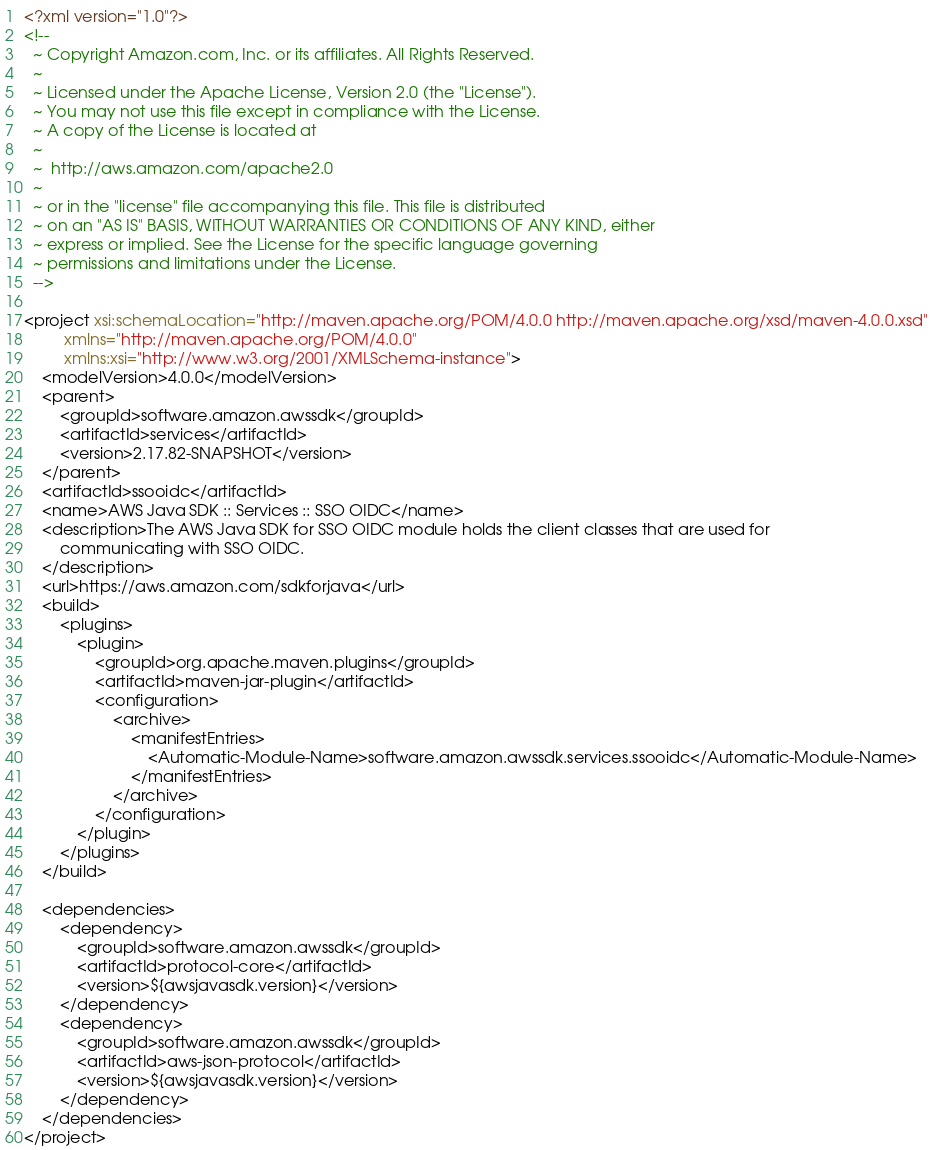<code> <loc_0><loc_0><loc_500><loc_500><_XML_><?xml version="1.0"?>
<!--
  ~ Copyright Amazon.com, Inc. or its affiliates. All Rights Reserved.
  ~
  ~ Licensed under the Apache License, Version 2.0 (the "License").
  ~ You may not use this file except in compliance with the License.
  ~ A copy of the License is located at
  ~
  ~  http://aws.amazon.com/apache2.0
  ~
  ~ or in the "license" file accompanying this file. This file is distributed
  ~ on an "AS IS" BASIS, WITHOUT WARRANTIES OR CONDITIONS OF ANY KIND, either
  ~ express or implied. See the License for the specific language governing
  ~ permissions and limitations under the License.
  -->

<project xsi:schemaLocation="http://maven.apache.org/POM/4.0.0 http://maven.apache.org/xsd/maven-4.0.0.xsd"
         xmlns="http://maven.apache.org/POM/4.0.0"
         xmlns:xsi="http://www.w3.org/2001/XMLSchema-instance">
    <modelVersion>4.0.0</modelVersion>
    <parent>
        <groupId>software.amazon.awssdk</groupId>
        <artifactId>services</artifactId>
        <version>2.17.82-SNAPSHOT</version>
    </parent>
    <artifactId>ssooidc</artifactId>
    <name>AWS Java SDK :: Services :: SSO OIDC</name>
    <description>The AWS Java SDK for SSO OIDC module holds the client classes that are used for
        communicating with SSO OIDC.
    </description>
    <url>https://aws.amazon.com/sdkforjava</url>
    <build>
        <plugins>
            <plugin>
                <groupId>org.apache.maven.plugins</groupId>
                <artifactId>maven-jar-plugin</artifactId>
                <configuration>
                    <archive>
                        <manifestEntries>
                            <Automatic-Module-Name>software.amazon.awssdk.services.ssooidc</Automatic-Module-Name>
                        </manifestEntries>
                    </archive>
                </configuration>
            </plugin>
        </plugins>
    </build>

    <dependencies>
        <dependency>
            <groupId>software.amazon.awssdk</groupId>
            <artifactId>protocol-core</artifactId>
            <version>${awsjavasdk.version}</version>
        </dependency>
        <dependency>
            <groupId>software.amazon.awssdk</groupId>
            <artifactId>aws-json-protocol</artifactId>
            <version>${awsjavasdk.version}</version>
        </dependency>
    </dependencies>
</project>
</code> 